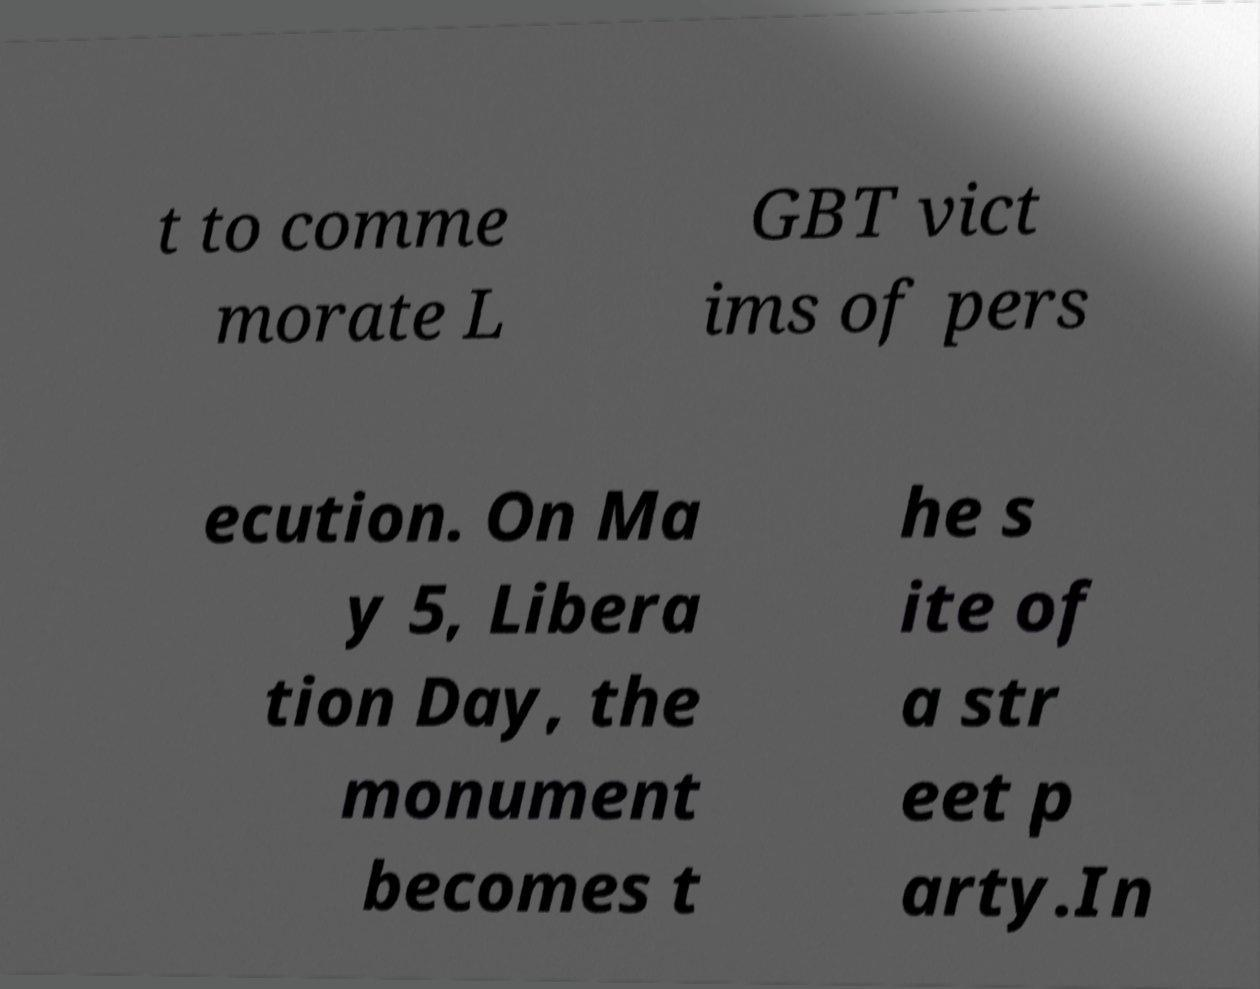There's text embedded in this image that I need extracted. Can you transcribe it verbatim? t to comme morate L GBT vict ims of pers ecution. On Ma y 5, Libera tion Day, the monument becomes t he s ite of a str eet p arty.In 